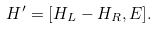Convert formula to latex. <formula><loc_0><loc_0><loc_500><loc_500>H ^ { \prime } = [ H _ { L } - H _ { R } , E ] .</formula> 